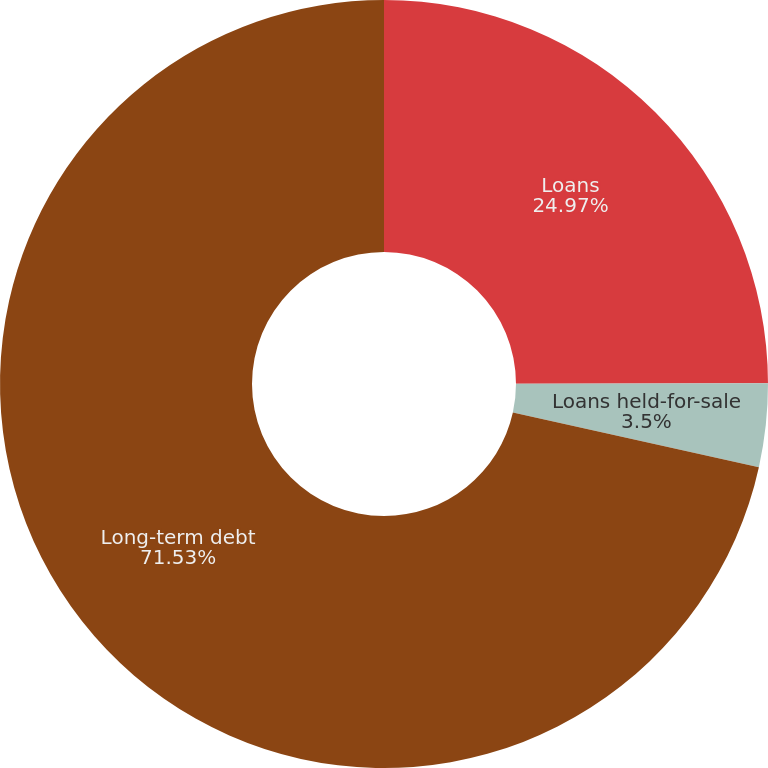Convert chart to OTSL. <chart><loc_0><loc_0><loc_500><loc_500><pie_chart><fcel>Loans<fcel>Loans held-for-sale<fcel>Long-term debt<nl><fcel>24.97%<fcel>3.5%<fcel>71.52%<nl></chart> 